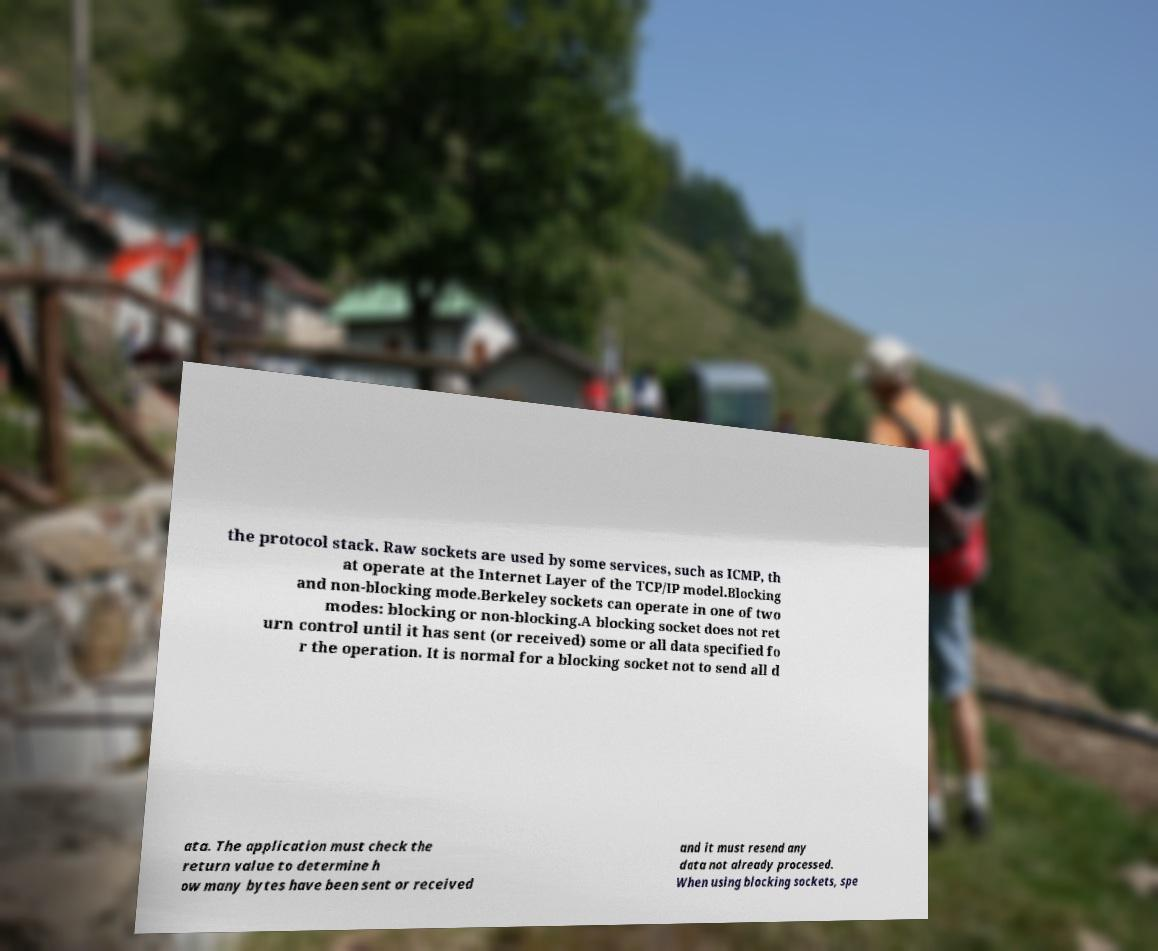Please identify and transcribe the text found in this image. the protocol stack. Raw sockets are used by some services, such as ICMP, th at operate at the Internet Layer of the TCP/IP model.Blocking and non-blocking mode.Berkeley sockets can operate in one of two modes: blocking or non-blocking.A blocking socket does not ret urn control until it has sent (or received) some or all data specified fo r the operation. It is normal for a blocking socket not to send all d ata. The application must check the return value to determine h ow many bytes have been sent or received and it must resend any data not already processed. When using blocking sockets, spe 